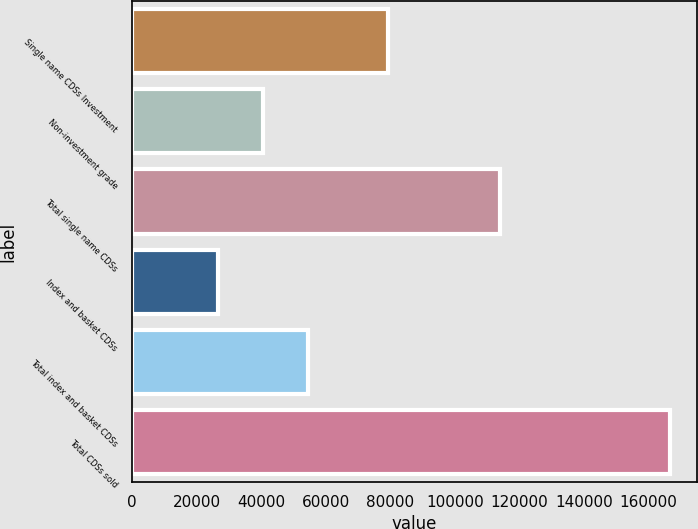<chart> <loc_0><loc_0><loc_500><loc_500><bar_chart><fcel>Single name CDSs Investment<fcel>Non-investment grade<fcel>Total single name CDSs<fcel>Index and basket CDSs<fcel>Total index and basket CDSs<fcel>Total CDSs sold<nl><fcel>79449<fcel>40545.5<fcel>114020<fcel>26530<fcel>54561<fcel>166685<nl></chart> 